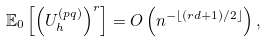Convert formula to latex. <formula><loc_0><loc_0><loc_500><loc_500>\mathbb { E } _ { 0 } \left [ \left ( U ^ { ( p q ) } _ { h } \right ) ^ { r } \right ] = O \left ( n ^ { - \lfloor ( r d + 1 ) / 2 \rfloor } \right ) ,</formula> 